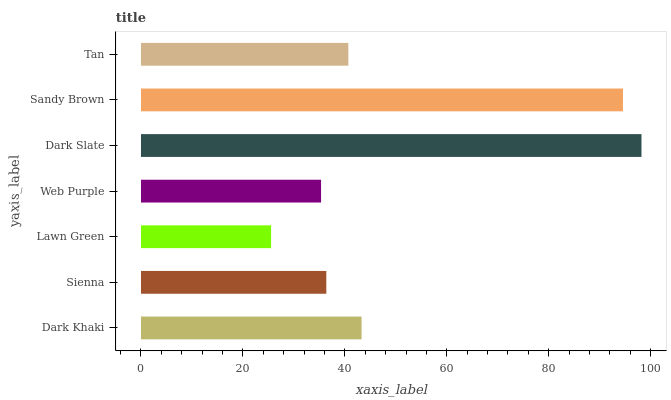Is Lawn Green the minimum?
Answer yes or no. Yes. Is Dark Slate the maximum?
Answer yes or no. Yes. Is Sienna the minimum?
Answer yes or no. No. Is Sienna the maximum?
Answer yes or no. No. Is Dark Khaki greater than Sienna?
Answer yes or no. Yes. Is Sienna less than Dark Khaki?
Answer yes or no. Yes. Is Sienna greater than Dark Khaki?
Answer yes or no. No. Is Dark Khaki less than Sienna?
Answer yes or no. No. Is Tan the high median?
Answer yes or no. Yes. Is Tan the low median?
Answer yes or no. Yes. Is Web Purple the high median?
Answer yes or no. No. Is Sienna the low median?
Answer yes or no. No. 